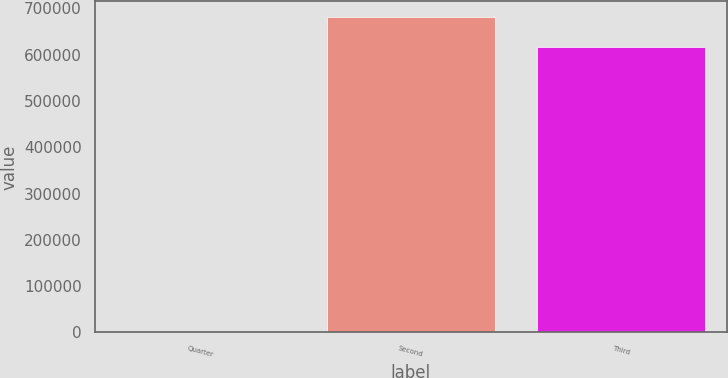<chart> <loc_0><loc_0><loc_500><loc_500><bar_chart><fcel>Quarter<fcel>Second<fcel>Third<nl><fcel>2008<fcel>680950<fcel>617538<nl></chart> 